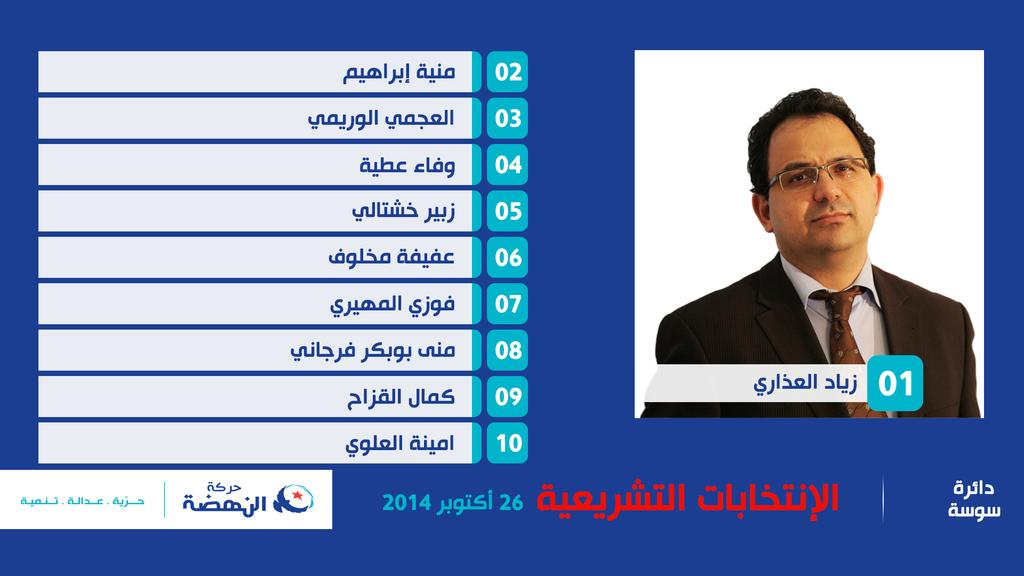What is located on the right side of the image? There is a person's image on the right side of the image. What can be seen on the left side of the image? There is a script and numbers on the left side of the image. What is present at the bottom of the image? There is a logo at the bottom of the image. How many pears are visible in the image? There are no pears present in the image. What type of class is being taught in the image? There is no class or teaching activity depicted in the image. 